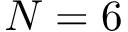<formula> <loc_0><loc_0><loc_500><loc_500>N = 6</formula> 